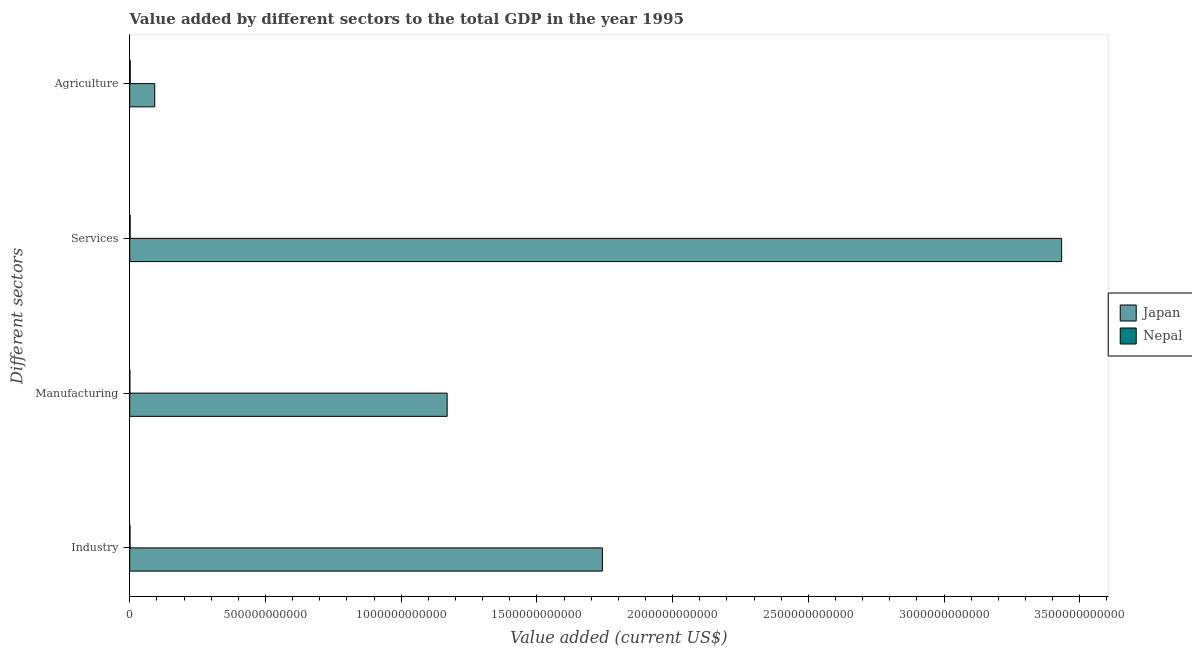How many different coloured bars are there?
Your response must be concise. 2. How many bars are there on the 2nd tick from the top?
Offer a very short reply. 2. How many bars are there on the 2nd tick from the bottom?
Make the answer very short. 2. What is the label of the 4th group of bars from the top?
Offer a very short reply. Industry. What is the value added by services sector in Nepal?
Your answer should be very brief. 1.46e+09. Across all countries, what is the maximum value added by agricultural sector?
Provide a succinct answer. 9.22e+1. Across all countries, what is the minimum value added by agricultural sector?
Provide a succinct answer. 1.72e+09. In which country was the value added by services sector minimum?
Make the answer very short. Nepal. What is the total value added by industrial sector in the graph?
Provide a short and direct response. 1.74e+12. What is the difference between the value added by services sector in Nepal and that in Japan?
Your response must be concise. -3.43e+12. What is the difference between the value added by services sector in Japan and the value added by industrial sector in Nepal?
Ensure brevity in your answer.  3.43e+12. What is the average value added by agricultural sector per country?
Offer a very short reply. 4.69e+1. What is the difference between the value added by services sector and value added by agricultural sector in Nepal?
Ensure brevity in your answer.  -2.58e+08. What is the ratio of the value added by services sector in Japan to that in Nepal?
Your answer should be compact. 2350.97. Is the value added by manufacturing sector in Japan less than that in Nepal?
Offer a very short reply. No. What is the difference between the highest and the second highest value added by manufacturing sector?
Provide a succinct answer. 1.17e+12. What is the difference between the highest and the lowest value added by services sector?
Your response must be concise. 3.43e+12. Is it the case that in every country, the sum of the value added by manufacturing sector and value added by agricultural sector is greater than the sum of value added by services sector and value added by industrial sector?
Make the answer very short. No. What does the 1st bar from the bottom in Industry represents?
Provide a succinct answer. Japan. Are all the bars in the graph horizontal?
Give a very brief answer. Yes. How many countries are there in the graph?
Give a very brief answer. 2. What is the difference between two consecutive major ticks on the X-axis?
Your answer should be compact. 5.00e+11. Are the values on the major ticks of X-axis written in scientific E-notation?
Keep it short and to the point. No. Does the graph contain grids?
Your response must be concise. No. Where does the legend appear in the graph?
Make the answer very short. Center right. How many legend labels are there?
Provide a short and direct response. 2. How are the legend labels stacked?
Provide a short and direct response. Vertical. What is the title of the graph?
Your answer should be very brief. Value added by different sectors to the total GDP in the year 1995. Does "Mexico" appear as one of the legend labels in the graph?
Provide a short and direct response. No. What is the label or title of the X-axis?
Provide a succinct answer. Value added (current US$). What is the label or title of the Y-axis?
Ensure brevity in your answer.  Different sectors. What is the Value added (current US$) in Japan in Industry?
Keep it short and to the point. 1.74e+12. What is the Value added (current US$) of Nepal in Industry?
Ensure brevity in your answer.  9.36e+08. What is the Value added (current US$) of Japan in Manufacturing?
Offer a very short reply. 1.17e+12. What is the Value added (current US$) of Nepal in Manufacturing?
Your answer should be very brief. 3.93e+08. What is the Value added (current US$) of Japan in Services?
Your answer should be very brief. 3.43e+12. What is the Value added (current US$) in Nepal in Services?
Your answer should be very brief. 1.46e+09. What is the Value added (current US$) in Japan in Agriculture?
Your answer should be very brief. 9.22e+1. What is the Value added (current US$) in Nepal in Agriculture?
Your answer should be very brief. 1.72e+09. Across all Different sectors, what is the maximum Value added (current US$) of Japan?
Give a very brief answer. 3.43e+12. Across all Different sectors, what is the maximum Value added (current US$) of Nepal?
Offer a terse response. 1.72e+09. Across all Different sectors, what is the minimum Value added (current US$) in Japan?
Your response must be concise. 9.22e+1. Across all Different sectors, what is the minimum Value added (current US$) of Nepal?
Provide a succinct answer. 3.93e+08. What is the total Value added (current US$) of Japan in the graph?
Ensure brevity in your answer.  6.44e+12. What is the total Value added (current US$) of Nepal in the graph?
Ensure brevity in your answer.  4.51e+09. What is the difference between the Value added (current US$) of Japan in Industry and that in Manufacturing?
Provide a short and direct response. 5.72e+11. What is the difference between the Value added (current US$) in Nepal in Industry and that in Manufacturing?
Keep it short and to the point. 5.44e+08. What is the difference between the Value added (current US$) in Japan in Industry and that in Services?
Keep it short and to the point. -1.69e+12. What is the difference between the Value added (current US$) of Nepal in Industry and that in Services?
Your response must be concise. -5.24e+08. What is the difference between the Value added (current US$) in Japan in Industry and that in Agriculture?
Keep it short and to the point. 1.65e+12. What is the difference between the Value added (current US$) of Nepal in Industry and that in Agriculture?
Your answer should be compact. -7.82e+08. What is the difference between the Value added (current US$) in Japan in Manufacturing and that in Services?
Offer a terse response. -2.26e+12. What is the difference between the Value added (current US$) in Nepal in Manufacturing and that in Services?
Make the answer very short. -1.07e+09. What is the difference between the Value added (current US$) in Japan in Manufacturing and that in Agriculture?
Give a very brief answer. 1.08e+12. What is the difference between the Value added (current US$) in Nepal in Manufacturing and that in Agriculture?
Offer a very short reply. -1.33e+09. What is the difference between the Value added (current US$) of Japan in Services and that in Agriculture?
Your answer should be very brief. 3.34e+12. What is the difference between the Value added (current US$) in Nepal in Services and that in Agriculture?
Make the answer very short. -2.58e+08. What is the difference between the Value added (current US$) of Japan in Industry and the Value added (current US$) of Nepal in Manufacturing?
Provide a succinct answer. 1.74e+12. What is the difference between the Value added (current US$) in Japan in Industry and the Value added (current US$) in Nepal in Services?
Keep it short and to the point. 1.74e+12. What is the difference between the Value added (current US$) in Japan in Industry and the Value added (current US$) in Nepal in Agriculture?
Your response must be concise. 1.74e+12. What is the difference between the Value added (current US$) of Japan in Manufacturing and the Value added (current US$) of Nepal in Services?
Keep it short and to the point. 1.17e+12. What is the difference between the Value added (current US$) of Japan in Manufacturing and the Value added (current US$) of Nepal in Agriculture?
Provide a succinct answer. 1.17e+12. What is the difference between the Value added (current US$) in Japan in Services and the Value added (current US$) in Nepal in Agriculture?
Your answer should be compact. 3.43e+12. What is the average Value added (current US$) of Japan per Different sectors?
Provide a succinct answer. 1.61e+12. What is the average Value added (current US$) in Nepal per Different sectors?
Your answer should be very brief. 1.13e+09. What is the difference between the Value added (current US$) in Japan and Value added (current US$) in Nepal in Industry?
Ensure brevity in your answer.  1.74e+12. What is the difference between the Value added (current US$) of Japan and Value added (current US$) of Nepal in Manufacturing?
Give a very brief answer. 1.17e+12. What is the difference between the Value added (current US$) of Japan and Value added (current US$) of Nepal in Services?
Provide a succinct answer. 3.43e+12. What is the difference between the Value added (current US$) of Japan and Value added (current US$) of Nepal in Agriculture?
Give a very brief answer. 9.05e+1. What is the ratio of the Value added (current US$) in Japan in Industry to that in Manufacturing?
Offer a very short reply. 1.49. What is the ratio of the Value added (current US$) of Nepal in Industry to that in Manufacturing?
Provide a succinct answer. 2.38. What is the ratio of the Value added (current US$) of Japan in Industry to that in Services?
Offer a very short reply. 0.51. What is the ratio of the Value added (current US$) of Nepal in Industry to that in Services?
Make the answer very short. 0.64. What is the ratio of the Value added (current US$) in Japan in Industry to that in Agriculture?
Make the answer very short. 18.89. What is the ratio of the Value added (current US$) of Nepal in Industry to that in Agriculture?
Ensure brevity in your answer.  0.54. What is the ratio of the Value added (current US$) in Japan in Manufacturing to that in Services?
Provide a short and direct response. 0.34. What is the ratio of the Value added (current US$) in Nepal in Manufacturing to that in Services?
Ensure brevity in your answer.  0.27. What is the ratio of the Value added (current US$) in Japan in Manufacturing to that in Agriculture?
Provide a short and direct response. 12.69. What is the ratio of the Value added (current US$) in Nepal in Manufacturing to that in Agriculture?
Make the answer very short. 0.23. What is the ratio of the Value added (current US$) in Japan in Services to that in Agriculture?
Offer a very short reply. 37.24. What is the ratio of the Value added (current US$) in Nepal in Services to that in Agriculture?
Offer a terse response. 0.85. What is the difference between the highest and the second highest Value added (current US$) in Japan?
Make the answer very short. 1.69e+12. What is the difference between the highest and the second highest Value added (current US$) in Nepal?
Your response must be concise. 2.58e+08. What is the difference between the highest and the lowest Value added (current US$) in Japan?
Your answer should be compact. 3.34e+12. What is the difference between the highest and the lowest Value added (current US$) in Nepal?
Your response must be concise. 1.33e+09. 